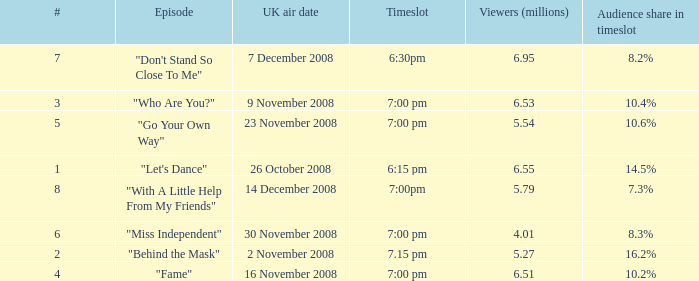Name the total number of viewers for audience share in timeslot for 10.2% 1.0. 